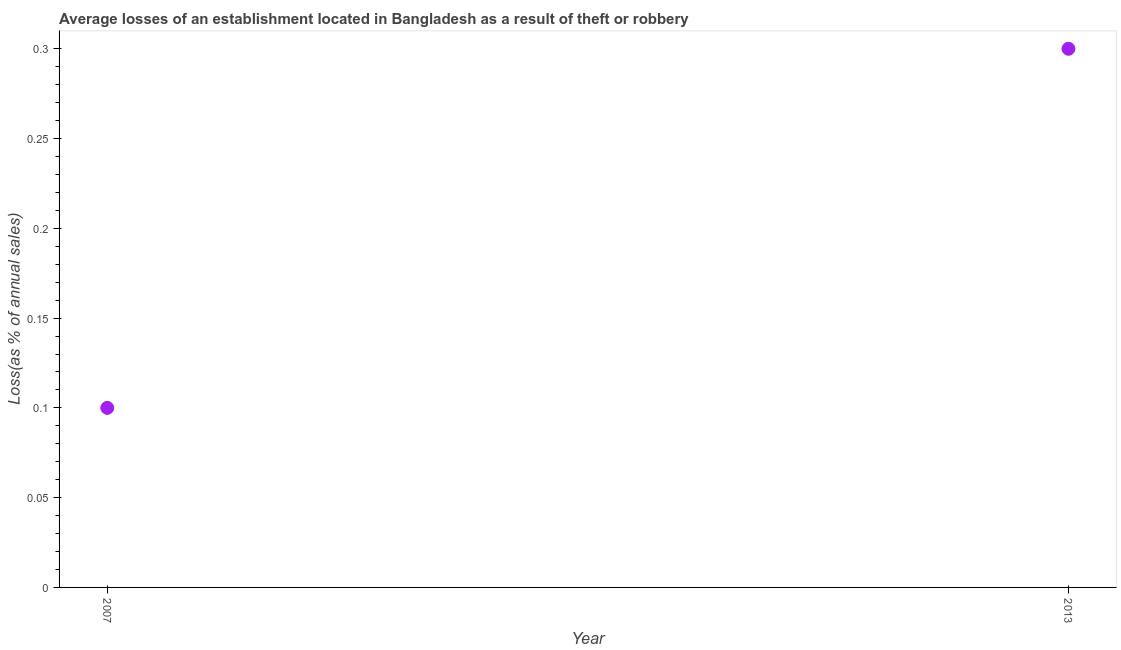Across all years, what is the minimum losses due to theft?
Provide a succinct answer. 0.1. In which year was the losses due to theft maximum?
Give a very brief answer. 2013. What is the sum of the losses due to theft?
Your answer should be very brief. 0.4. What is the difference between the losses due to theft in 2007 and 2013?
Your response must be concise. -0.2. What is the median losses due to theft?
Give a very brief answer. 0.2. What is the ratio of the losses due to theft in 2007 to that in 2013?
Make the answer very short. 0.33. In how many years, is the losses due to theft greater than the average losses due to theft taken over all years?
Your answer should be compact. 1. Does the losses due to theft monotonically increase over the years?
Make the answer very short. Yes. Does the graph contain grids?
Offer a terse response. No. What is the title of the graph?
Give a very brief answer. Average losses of an establishment located in Bangladesh as a result of theft or robbery. What is the label or title of the Y-axis?
Keep it short and to the point. Loss(as % of annual sales). What is the Loss(as % of annual sales) in 2013?
Provide a succinct answer. 0.3. What is the difference between the Loss(as % of annual sales) in 2007 and 2013?
Offer a terse response. -0.2. What is the ratio of the Loss(as % of annual sales) in 2007 to that in 2013?
Keep it short and to the point. 0.33. 